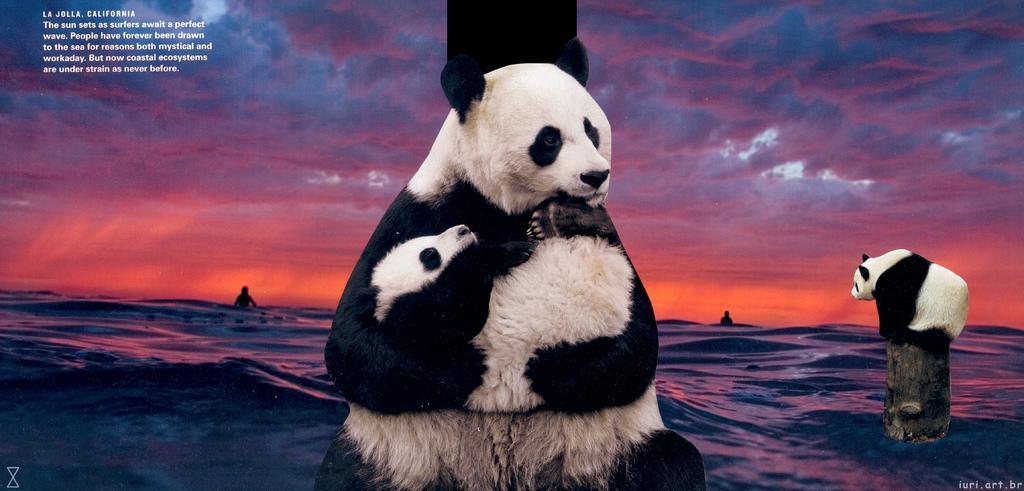How would you summarize this image in a sentence or two? In this edited image there are panda. In the center there is a panda holding a baby panda in its hand. Behind it there is tree trunk. To the right there is another panda on a tree trunk. Behind them there is water. Behind them there is the water. There are two persons in the image. At the top there is the sky. 